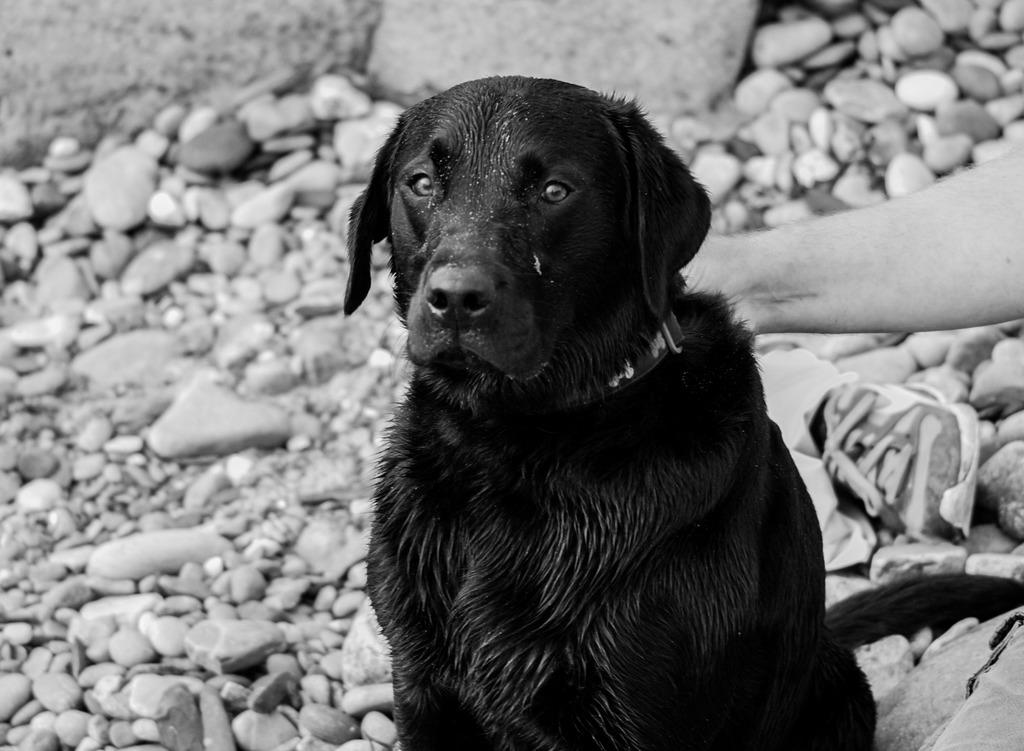What is the main subject in the center of the image? There is a dog in the center of the image. What can be seen on the right side of the image? There is a person's hand on the right side of the image. What type of landscape is visible in the background of the image? There are stones visible in the background of the image. What else can be seen in the background of the image? There is a shoe in the background of the image. How long does it take for the dog to match the color of the shoe in the image? There is no indication in the image that the dog is trying to match the color of the shoe, and therefore no such activity can be observed. 